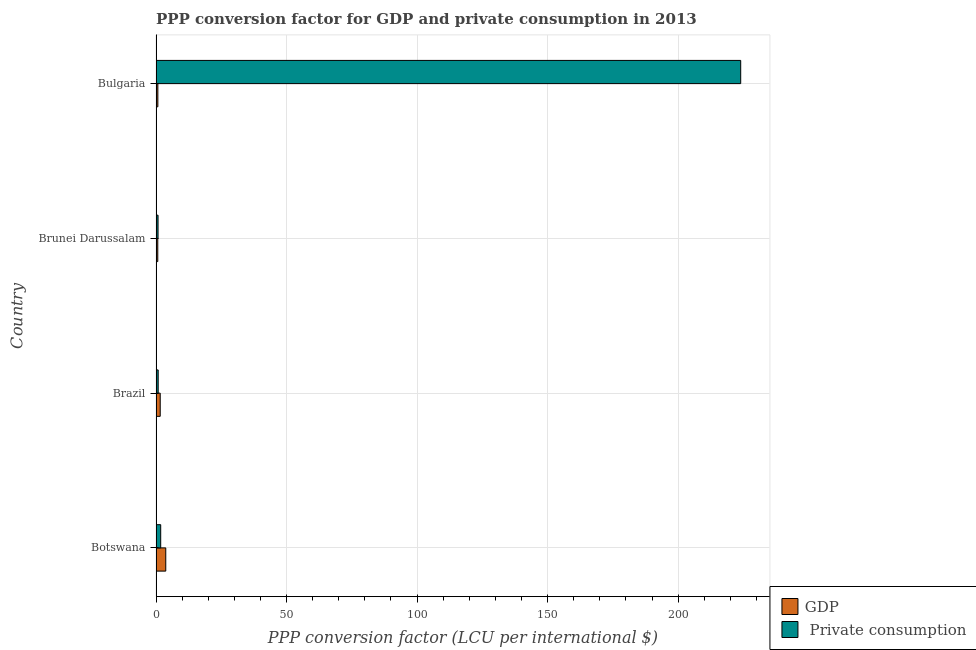How many different coloured bars are there?
Make the answer very short. 2. Are the number of bars on each tick of the Y-axis equal?
Offer a very short reply. Yes. What is the label of the 3rd group of bars from the top?
Offer a terse response. Brazil. In how many cases, is the number of bars for a given country not equal to the number of legend labels?
Ensure brevity in your answer.  0. What is the ppp conversion factor for private consumption in Brazil?
Provide a succinct answer. 0.83. Across all countries, what is the maximum ppp conversion factor for gdp?
Your answer should be compact. 3.73. Across all countries, what is the minimum ppp conversion factor for gdp?
Offer a terse response. 0.67. In which country was the ppp conversion factor for private consumption maximum?
Your answer should be very brief. Bulgaria. In which country was the ppp conversion factor for private consumption minimum?
Your response must be concise. Brunei Darussalam. What is the total ppp conversion factor for private consumption in the graph?
Offer a very short reply. 227.38. What is the difference between the ppp conversion factor for gdp in Botswana and that in Brunei Darussalam?
Your response must be concise. 3.06. What is the difference between the ppp conversion factor for private consumption in Botswana and the ppp conversion factor for gdp in Brunei Darussalam?
Your answer should be very brief. 1.12. What is the average ppp conversion factor for private consumption per country?
Give a very brief answer. 56.84. What is the difference between the ppp conversion factor for private consumption and ppp conversion factor for gdp in Brunei Darussalam?
Ensure brevity in your answer.  0.1. What is the ratio of the ppp conversion factor for gdp in Brazil to that in Brunei Darussalam?
Offer a very short reply. 2.39. Is the ppp conversion factor for private consumption in Brazil less than that in Bulgaria?
Provide a succinct answer. Yes. What is the difference between the highest and the second highest ppp conversion factor for private consumption?
Provide a short and direct response. 222.18. What is the difference between the highest and the lowest ppp conversion factor for private consumption?
Provide a short and direct response. 223.2. In how many countries, is the ppp conversion factor for private consumption greater than the average ppp conversion factor for private consumption taken over all countries?
Provide a short and direct response. 1. What does the 2nd bar from the top in Brunei Darussalam represents?
Offer a terse response. GDP. What does the 1st bar from the bottom in Bulgaria represents?
Your answer should be very brief. GDP. What is the difference between two consecutive major ticks on the X-axis?
Offer a terse response. 50. Does the graph contain grids?
Your answer should be very brief. Yes. How many legend labels are there?
Offer a terse response. 2. What is the title of the graph?
Give a very brief answer. PPP conversion factor for GDP and private consumption in 2013. What is the label or title of the X-axis?
Ensure brevity in your answer.  PPP conversion factor (LCU per international $). What is the PPP conversion factor (LCU per international $) of GDP in Botswana?
Your response must be concise. 3.73. What is the PPP conversion factor (LCU per international $) in  Private consumption in Botswana?
Your answer should be compact. 1.79. What is the PPP conversion factor (LCU per international $) in GDP in Brazil?
Offer a terse response. 1.61. What is the PPP conversion factor (LCU per international $) in  Private consumption in Brazil?
Your answer should be very brief. 0.83. What is the PPP conversion factor (LCU per international $) in GDP in Brunei Darussalam?
Offer a very short reply. 0.67. What is the PPP conversion factor (LCU per international $) of  Private consumption in Brunei Darussalam?
Your response must be concise. 0.78. What is the PPP conversion factor (LCU per international $) of GDP in Bulgaria?
Give a very brief answer. 0.7. What is the PPP conversion factor (LCU per international $) in  Private consumption in Bulgaria?
Keep it short and to the point. 223.98. Across all countries, what is the maximum PPP conversion factor (LCU per international $) of GDP?
Keep it short and to the point. 3.73. Across all countries, what is the maximum PPP conversion factor (LCU per international $) in  Private consumption?
Offer a terse response. 223.98. Across all countries, what is the minimum PPP conversion factor (LCU per international $) in GDP?
Ensure brevity in your answer.  0.67. Across all countries, what is the minimum PPP conversion factor (LCU per international $) of  Private consumption?
Make the answer very short. 0.78. What is the total PPP conversion factor (LCU per international $) in GDP in the graph?
Give a very brief answer. 6.71. What is the total PPP conversion factor (LCU per international $) in  Private consumption in the graph?
Provide a succinct answer. 227.38. What is the difference between the PPP conversion factor (LCU per international $) in GDP in Botswana and that in Brazil?
Your answer should be compact. 2.12. What is the difference between the PPP conversion factor (LCU per international $) of  Private consumption in Botswana and that in Brazil?
Offer a terse response. 0.96. What is the difference between the PPP conversion factor (LCU per international $) in GDP in Botswana and that in Brunei Darussalam?
Make the answer very short. 3.06. What is the difference between the PPP conversion factor (LCU per international $) in GDP in Botswana and that in Bulgaria?
Provide a succinct answer. 3.03. What is the difference between the PPP conversion factor (LCU per international $) of  Private consumption in Botswana and that in Bulgaria?
Provide a short and direct response. -222.18. What is the difference between the PPP conversion factor (LCU per international $) in GDP in Brazil and that in Brunei Darussalam?
Offer a terse response. 0.93. What is the difference between the PPP conversion factor (LCU per international $) of  Private consumption in Brazil and that in Brunei Darussalam?
Make the answer very short. 0.05. What is the difference between the PPP conversion factor (LCU per international $) of GDP in Brazil and that in Bulgaria?
Provide a short and direct response. 0.9. What is the difference between the PPP conversion factor (LCU per international $) of  Private consumption in Brazil and that in Bulgaria?
Offer a very short reply. -223.15. What is the difference between the PPP conversion factor (LCU per international $) of GDP in Brunei Darussalam and that in Bulgaria?
Ensure brevity in your answer.  -0.03. What is the difference between the PPP conversion factor (LCU per international $) of  Private consumption in Brunei Darussalam and that in Bulgaria?
Your answer should be compact. -223.2. What is the difference between the PPP conversion factor (LCU per international $) of GDP in Botswana and the PPP conversion factor (LCU per international $) of  Private consumption in Brazil?
Offer a very short reply. 2.9. What is the difference between the PPP conversion factor (LCU per international $) of GDP in Botswana and the PPP conversion factor (LCU per international $) of  Private consumption in Brunei Darussalam?
Your response must be concise. 2.95. What is the difference between the PPP conversion factor (LCU per international $) in GDP in Botswana and the PPP conversion factor (LCU per international $) in  Private consumption in Bulgaria?
Provide a succinct answer. -220.25. What is the difference between the PPP conversion factor (LCU per international $) in GDP in Brazil and the PPP conversion factor (LCU per international $) in  Private consumption in Brunei Darussalam?
Keep it short and to the point. 0.83. What is the difference between the PPP conversion factor (LCU per international $) in GDP in Brazil and the PPP conversion factor (LCU per international $) in  Private consumption in Bulgaria?
Your response must be concise. -222.37. What is the difference between the PPP conversion factor (LCU per international $) in GDP in Brunei Darussalam and the PPP conversion factor (LCU per international $) in  Private consumption in Bulgaria?
Provide a succinct answer. -223.3. What is the average PPP conversion factor (LCU per international $) of GDP per country?
Make the answer very short. 1.68. What is the average PPP conversion factor (LCU per international $) in  Private consumption per country?
Make the answer very short. 56.84. What is the difference between the PPP conversion factor (LCU per international $) of GDP and PPP conversion factor (LCU per international $) of  Private consumption in Botswana?
Your answer should be very brief. 1.94. What is the difference between the PPP conversion factor (LCU per international $) in GDP and PPP conversion factor (LCU per international $) in  Private consumption in Brazil?
Make the answer very short. 0.78. What is the difference between the PPP conversion factor (LCU per international $) in GDP and PPP conversion factor (LCU per international $) in  Private consumption in Brunei Darussalam?
Your response must be concise. -0.1. What is the difference between the PPP conversion factor (LCU per international $) in GDP and PPP conversion factor (LCU per international $) in  Private consumption in Bulgaria?
Your answer should be very brief. -223.27. What is the ratio of the PPP conversion factor (LCU per international $) of GDP in Botswana to that in Brazil?
Keep it short and to the point. 2.32. What is the ratio of the PPP conversion factor (LCU per international $) in  Private consumption in Botswana to that in Brazil?
Ensure brevity in your answer.  2.16. What is the ratio of the PPP conversion factor (LCU per international $) of GDP in Botswana to that in Brunei Darussalam?
Offer a terse response. 5.55. What is the ratio of the PPP conversion factor (LCU per international $) of  Private consumption in Botswana to that in Brunei Darussalam?
Offer a very short reply. 2.31. What is the ratio of the PPP conversion factor (LCU per international $) of GDP in Botswana to that in Bulgaria?
Your answer should be compact. 5.31. What is the ratio of the PPP conversion factor (LCU per international $) in  Private consumption in Botswana to that in Bulgaria?
Your response must be concise. 0.01. What is the ratio of the PPP conversion factor (LCU per international $) of GDP in Brazil to that in Brunei Darussalam?
Give a very brief answer. 2.39. What is the ratio of the PPP conversion factor (LCU per international $) in  Private consumption in Brazil to that in Brunei Darussalam?
Give a very brief answer. 1.07. What is the ratio of the PPP conversion factor (LCU per international $) in GDP in Brazil to that in Bulgaria?
Your answer should be compact. 2.29. What is the ratio of the PPP conversion factor (LCU per international $) of  Private consumption in Brazil to that in Bulgaria?
Your response must be concise. 0. What is the ratio of the PPP conversion factor (LCU per international $) of  Private consumption in Brunei Darussalam to that in Bulgaria?
Your answer should be very brief. 0. What is the difference between the highest and the second highest PPP conversion factor (LCU per international $) in GDP?
Provide a short and direct response. 2.12. What is the difference between the highest and the second highest PPP conversion factor (LCU per international $) of  Private consumption?
Keep it short and to the point. 222.18. What is the difference between the highest and the lowest PPP conversion factor (LCU per international $) in GDP?
Ensure brevity in your answer.  3.06. What is the difference between the highest and the lowest PPP conversion factor (LCU per international $) of  Private consumption?
Your response must be concise. 223.2. 